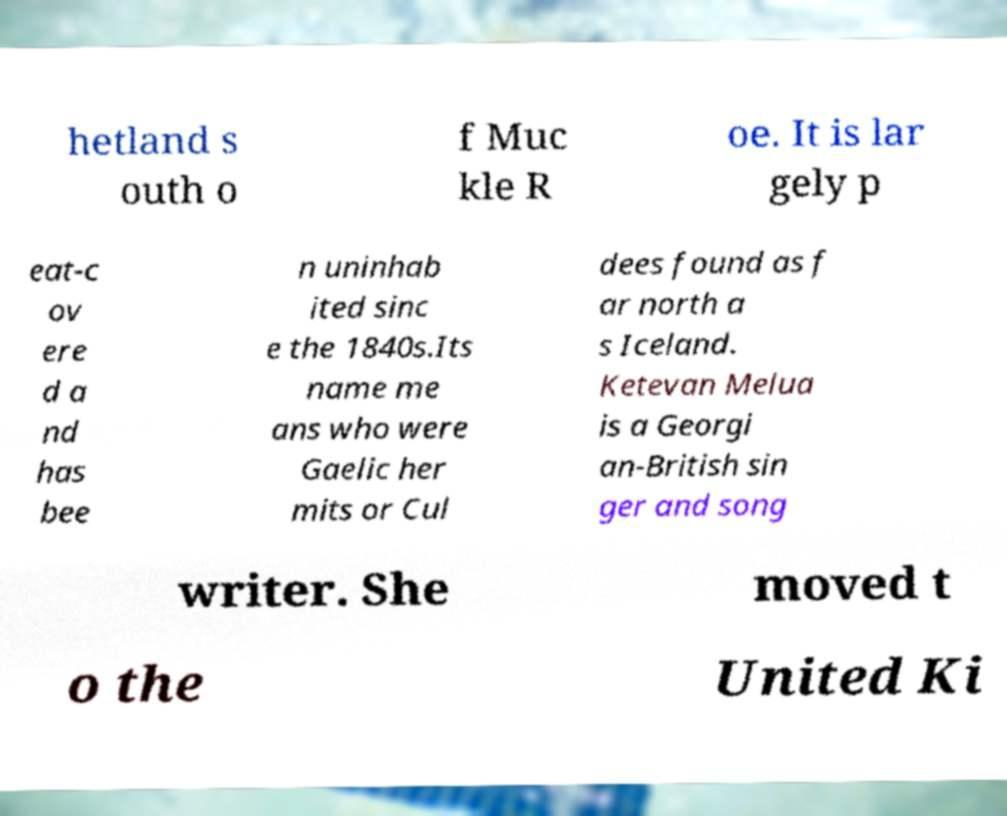For documentation purposes, I need the text within this image transcribed. Could you provide that? hetland s outh o f Muc kle R oe. It is lar gely p eat-c ov ere d a nd has bee n uninhab ited sinc e the 1840s.Its name me ans who were Gaelic her mits or Cul dees found as f ar north a s Iceland. Ketevan Melua is a Georgi an-British sin ger and song writer. She moved t o the United Ki 